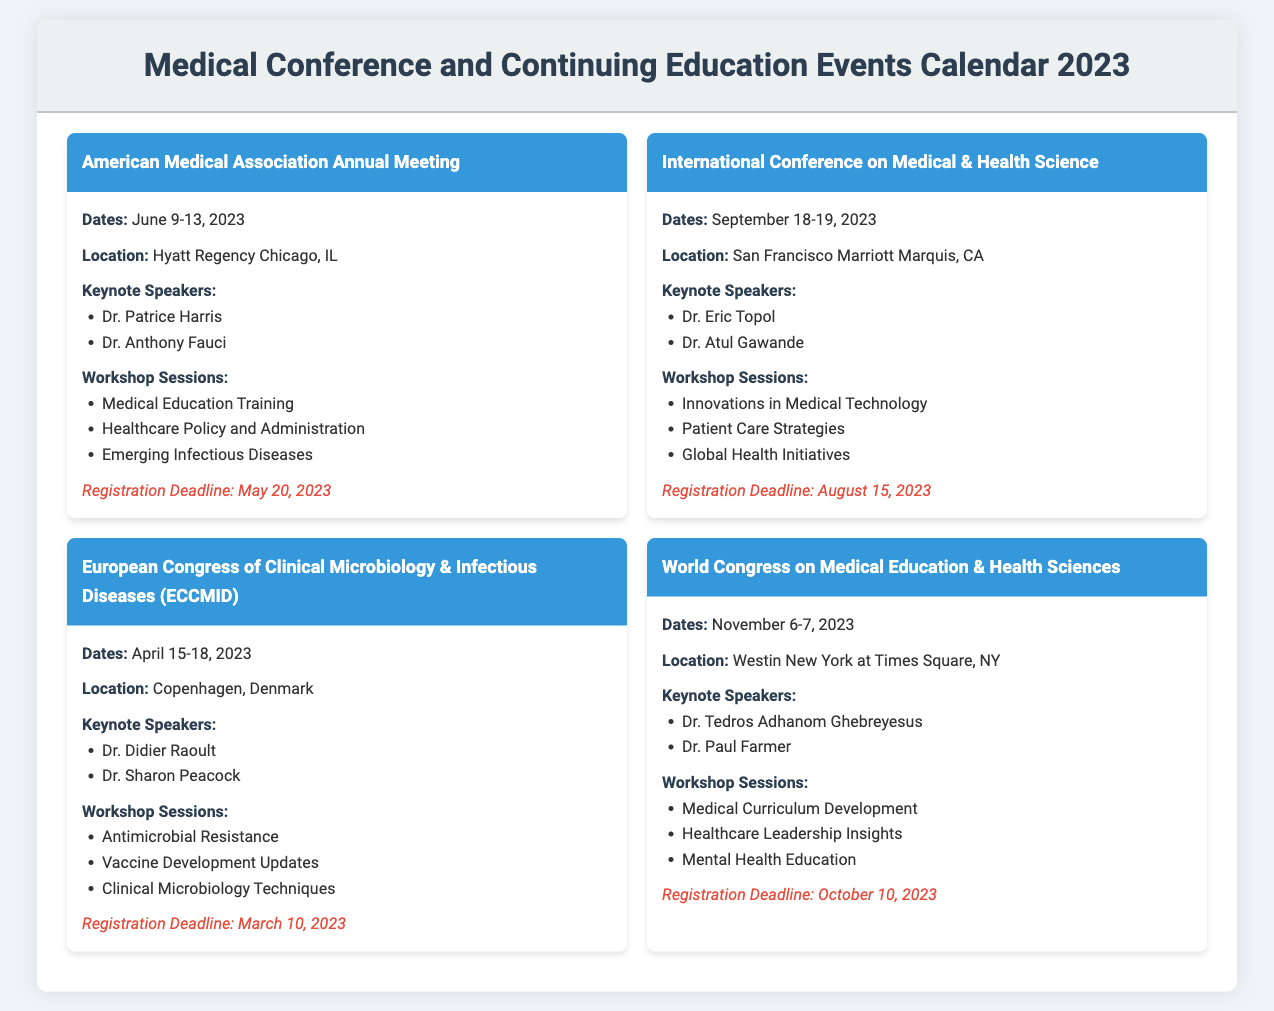What are the dates for the American Medical Association Annual Meeting? The event dates for the American Medical Association Annual Meeting can be found in the event information section of the document.
Answer: June 9-13, 2023 Who are the keynote speakers for the European Congress of Clinical Microbiology & Infectious Diseases? The document includes a list of keynote speakers for each event. For the European Congress, two speakers are provided.
Answer: Dr. Didier Raoult, Dr. Sharon Peacock What is the registration deadline for the World Congress on Medical Education & Health Sciences? The registration deadline is specifically mentioned in the event details of the document.
Answer: October 10, 2023 Where is the International Conference on Medical & Health Science located? The location of the International Conference is listed in the event information section.
Answer: San Francisco Marriott Marquis, CA How many workshop sessions are mentioned for the American Medical Association Annual Meeting? The number of workshop sessions can be counted from the details provided about the workshops in the document.
Answer: Three Which keynote speaker is associated with the World Congress on Medical Education & Health Sciences? The document specifies keynote speakers for this event, listing them in the event's body.
Answer: Dr. Tedros Adhanom Ghebreyesus What is the location of the European Congress of Clinical Microbiology & Infectious Diseases? The location is clearly stated in the event information.
Answer: Copenhagen, Denmark What are the dates for the International Conference on Medical & Health Science? The specific dates for this event are listed in the event details section of the document.
Answer: September 18-19, 2023 